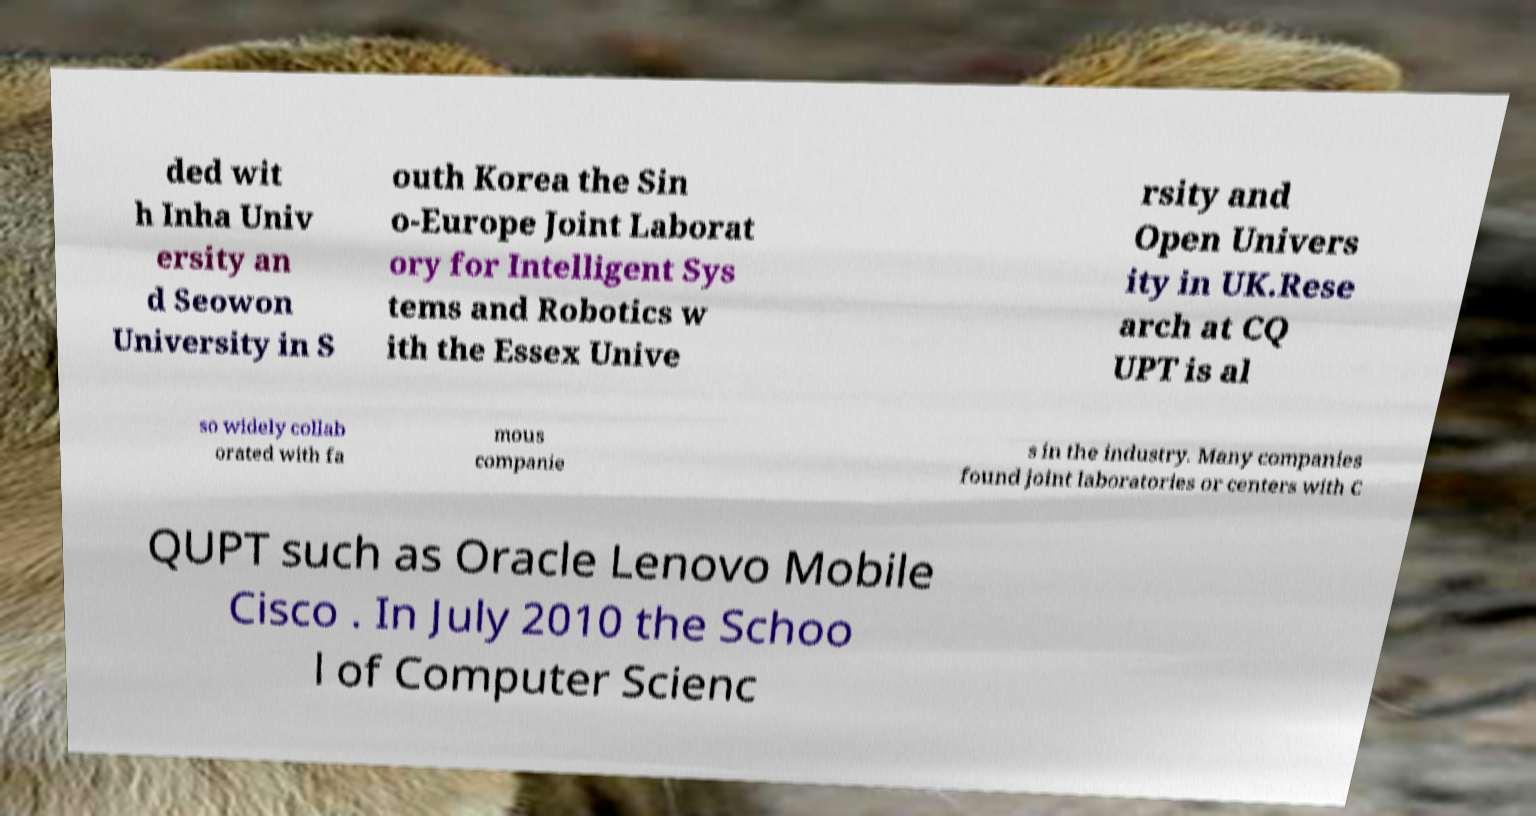For documentation purposes, I need the text within this image transcribed. Could you provide that? ded wit h Inha Univ ersity an d Seowon University in S outh Korea the Sin o-Europe Joint Laborat ory for Intelligent Sys tems and Robotics w ith the Essex Unive rsity and Open Univers ity in UK.Rese arch at CQ UPT is al so widely collab orated with fa mous companie s in the industry. Many companies found joint laboratories or centers with C QUPT such as Oracle Lenovo Mobile Cisco . In July 2010 the Schoo l of Computer Scienc 